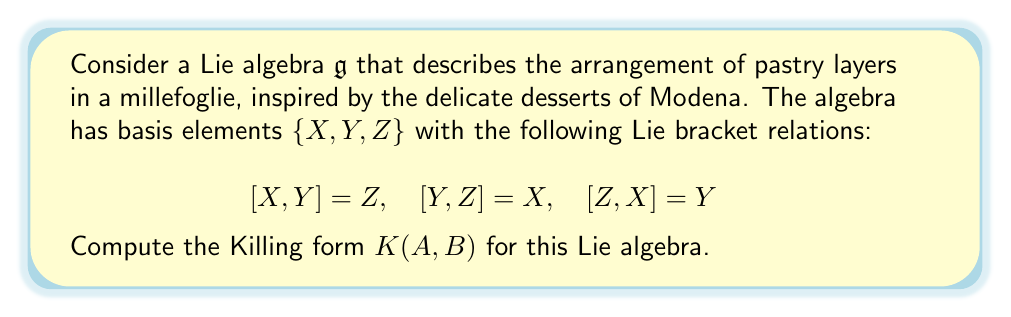Show me your answer to this math problem. To compute the Killing form for this Lie algebra, we'll follow these steps:

1) The Killing form is defined as $K(A,B) = \text{tr}(\text{ad}(A) \circ \text{ad}(B))$, where $\text{ad}(A)$ is the adjoint representation of $A$.

2) First, we need to find the matrix representations of $\text{ad}(X)$, $\text{ad}(Y)$, and $\text{ad}(Z)$ with respect to the given basis.

3) For $\text{ad}(X)$:
   $$\text{ad}(X)(X) = 0$$
   $$\text{ad}(X)(Y) = [X,Y] = Z$$
   $$\text{ad}(X)(Z) = [X,Z] = -Y$$

   So, $\text{ad}(X) = \begin{pmatrix} 0 & 0 & 0 \\ 0 & 0 & -1 \\ 0 & 1 & 0 \end{pmatrix}$

4) Similarly, we can compute:
   $\text{ad}(Y) = \begin{pmatrix} 0 & 0 & 1 \\ 0 & 0 & 0 \\ -1 & 0 & 0 \end{pmatrix}$
   $\text{ad}(Z) = \begin{pmatrix} 0 & -1 & 0 \\ 1 & 0 & 0 \\ 0 & 0 & 0 \end{pmatrix}$

5) Now, we can compute $K(A,B)$ for all pairs of basis elements:

   $K(X,X) = \text{tr}(\text{ad}(X) \circ \text{ad}(X)) = -2$
   $K(Y,Y) = \text{tr}(\text{ad}(Y) \circ \text{ad}(Y)) = -2$
   $K(Z,Z) = \text{tr}(\text{ad}(Z) \circ \text{ad}(Z)) = -2$
   $K(X,Y) = K(Y,X) = \text{tr}(\text{ad}(X) \circ \text{ad}(Y)) = 0$
   $K(X,Z) = K(Z,X) = \text{tr}(\text{ad}(X) \circ \text{ad}(Z)) = 0$
   $K(Y,Z) = K(Z,Y) = \text{tr}(\text{ad}(Y) \circ \text{ad}(Z)) = 0$

6) Therefore, the Killing form can be represented as a matrix:

   $$K = \begin{pmatrix} -2 & 0 & 0 \\ 0 & -2 & 0 \\ 0 & 0 & -2 \end{pmatrix}$$

This Killing form represents the symmetry in the arrangement of pastry layers in a millefoglie, where each layer contributes equally to the overall structure of the dessert.
Answer: The Killing form for the given Lie algebra is:

$$K = \begin{pmatrix} -2 & 0 & 0 \\ 0 & -2 & 0 \\ 0 & 0 & -2 \end{pmatrix}$$ 